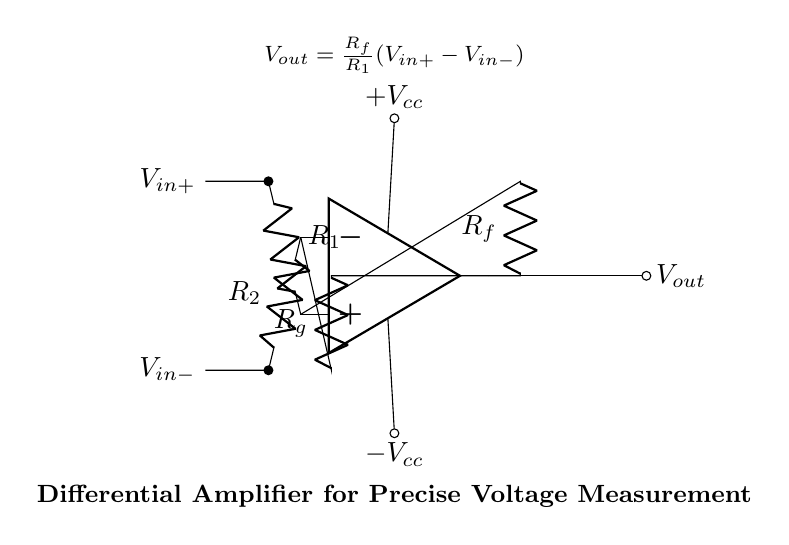What are the input voltages of the differential amplifier? The circuit indicates two input nodes: V_in+ is at the top with voltage R1 connected, and V_in- is at the bottom with voltage R2 connected. These labels directly identify the inputs.
Answer: V_in+ and V_in- What is the formula for the output voltage? The output voltage formula, V_out, displayed in the circuit is derived from the configuration of the resistors and the input voltages, showing how the output is proportional to the differential input voltage.
Answer: V_out = R_f/R_1 (V_in+ - V_in-) What is the role of R_f in the circuit? R_f functions as the feedback resistor, influencing the gain of the amplifier by determining how the input voltages proportionally affect the output voltage based on the feedback mechanism.
Answer: Gain control How many resistors are present in this circuit? The diagram shows a total of four resistors: R1, R2, R_f, and R_g, all of which are essential for the functioning of the differential amplifier in controlling the input voltage and feedback.
Answer: Four If R1 is doubled, what happens to the output voltage? Doubling R1 while keeping R_f constant will change the gain, as the output voltage is directly proportional to R_f/R_1. This indicates a reduction in output voltage for the same input differential voltage due to the increased denominator.
Answer: Decreases What are the power supply voltages in the circuit? The circuit shows clearly labeled power supply connections marked as +V_cc and -V_cc, which indicate the positive and negative supply voltages necessary for the operation of the op-amp.
Answer: +V_cc and -V_cc What type of amplifier is represented in the circuit? The circuit structure indicates it is a differential amplifier, specifically designed for measuring the difference between two input voltages while rejecting any common-mode noise.
Answer: Differential amplifier 